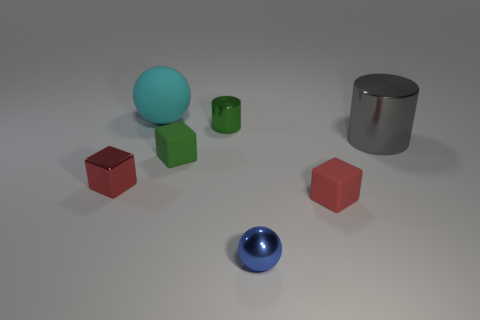There is a small red thing that is the same material as the blue sphere; what shape is it?
Offer a terse response. Cube. Does the ball that is behind the green cylinder have the same size as the red object that is to the right of the tiny green metallic thing?
Ensure brevity in your answer.  No. There is a cube that is right of the blue ball; what color is it?
Your response must be concise. Red. What is the material of the red object that is on the right side of the cylinder behind the big gray thing?
Ensure brevity in your answer.  Rubber. What is the shape of the tiny green matte object?
Your response must be concise. Cube. There is another small red thing that is the same shape as the red shiny object; what material is it?
Offer a terse response. Rubber. How many gray shiny objects are the same size as the blue metallic sphere?
Your answer should be very brief. 0. Is there a tiny metallic ball in front of the large object that is to the right of the tiny cylinder?
Give a very brief answer. Yes. How many yellow things are cubes or large spheres?
Make the answer very short. 0. The large cylinder has what color?
Your answer should be compact. Gray. 